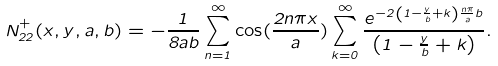Convert formula to latex. <formula><loc_0><loc_0><loc_500><loc_500>N _ { 2 2 } ^ { + } ( x , y , a , b ) = - \frac { 1 } { 8 a b } \sum _ { n = 1 } ^ { \infty } \cos ( \frac { 2 n \pi x } { a } ) \sum _ { k = 0 } ^ { \infty } \frac { e ^ { - 2 \left ( 1 - \frac { y } { b } + k \right ) \frac { n \pi } { a } b } } { \left ( 1 - \frac { y } { b } + k \right ) } .</formula> 